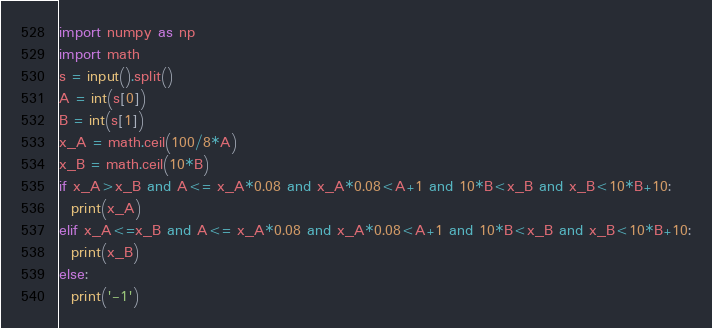<code> <loc_0><loc_0><loc_500><loc_500><_Python_>import numpy as np
import math
s = input().split()
A = int(s[0])
B = int(s[1])
x_A = math.ceil(100/8*A)
x_B = math.ceil(10*B)
if x_A>x_B and A<= x_A*0.08 and x_A*0.08<A+1 and 10*B<x_B and x_B<10*B+10:
  print(x_A)
elif x_A<=x_B and A<= x_A*0.08 and x_A*0.08<A+1 and 10*B<x_B and x_B<10*B+10:
  print(x_B)
else:
  print('-1')</code> 